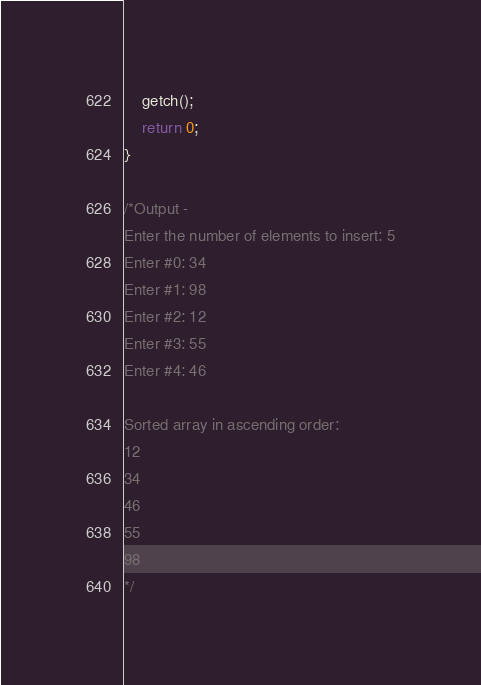<code> <loc_0><loc_0><loc_500><loc_500><_C_>
	getch();
	return 0;
}

/*Output -
Enter the number of elements to insert: 5
Enter #0: 34
Enter #1: 98
Enter #2: 12
Enter #3: 55
Enter #4: 46

Sorted array in ascending order:
12
34
46
55
98
*/</code> 